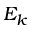<formula> <loc_0><loc_0><loc_500><loc_500>E _ { k }</formula> 